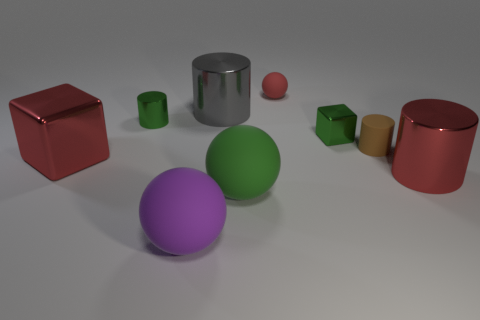What number of green objects are in front of the tiny shiny thing on the left side of the cylinder behind the small green cylinder?
Provide a succinct answer. 2. Are there fewer gray rubber cylinders than red objects?
Offer a very short reply. Yes. There is a large red metal thing that is in front of the big block; does it have the same shape as the small rubber thing in front of the red rubber sphere?
Your response must be concise. Yes. The tiny metal cube has what color?
Your answer should be very brief. Green. What number of shiny things are either purple spheres or small brown blocks?
Offer a terse response. 0. There is a small shiny object that is the same shape as the brown matte object; what color is it?
Keep it short and to the point. Green. Is there a cyan metal thing?
Your answer should be compact. No. Is the small cylinder that is on the left side of the purple rubber object made of the same material as the gray thing that is behind the green metal cylinder?
Provide a short and direct response. Yes. What shape is the big thing that is the same color as the tiny shiny cube?
Your answer should be compact. Sphere. How many objects are green cubes on the right side of the red shiny cube or red things that are right of the purple rubber object?
Offer a very short reply. 3. 